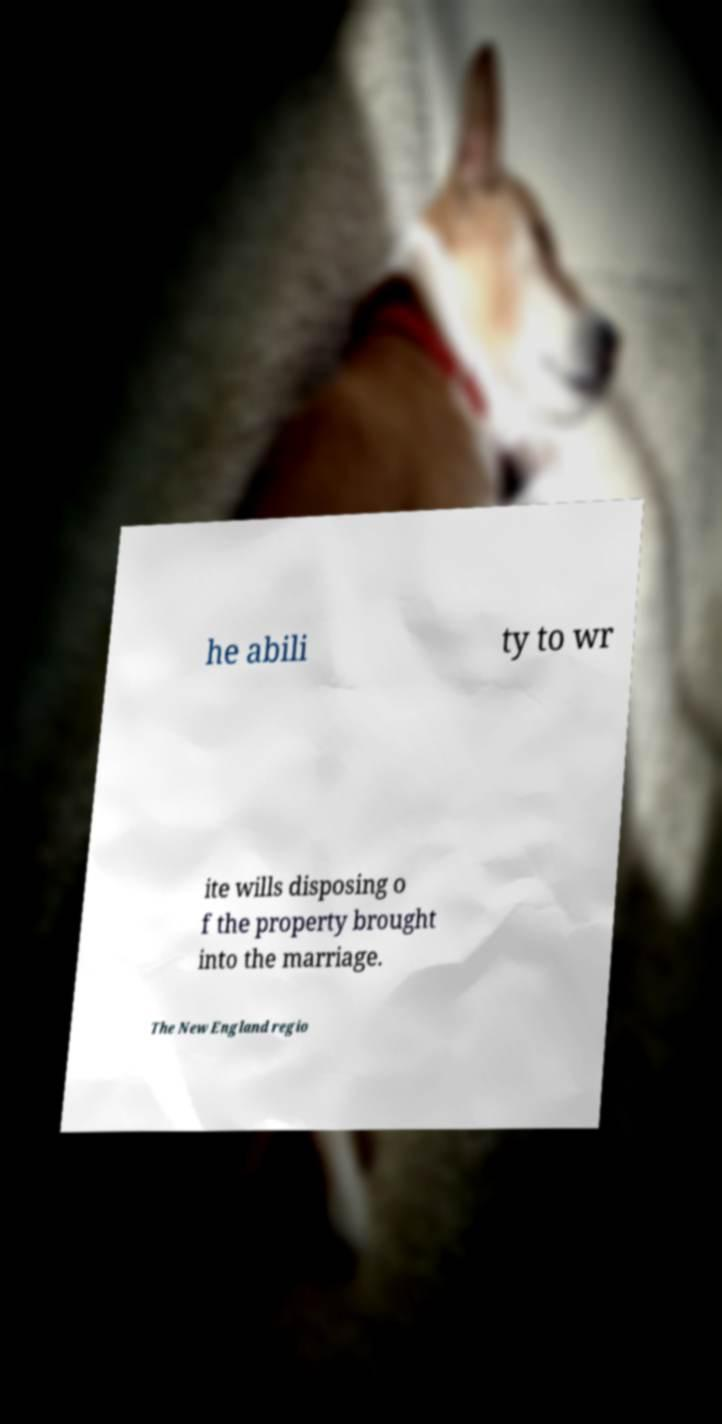Can you accurately transcribe the text from the provided image for me? he abili ty to wr ite wills disposing o f the property brought into the marriage. The New England regio 